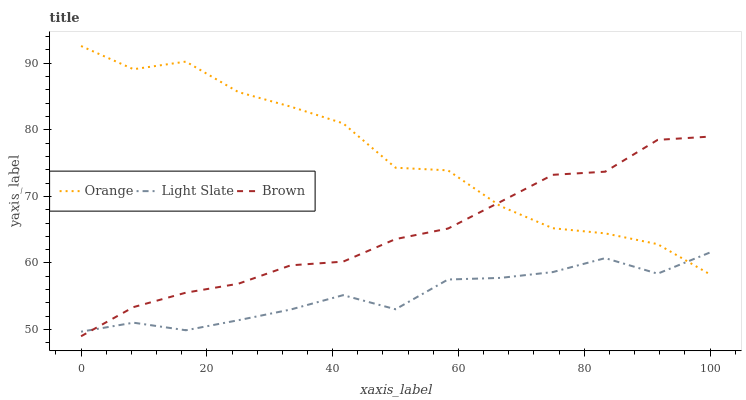Does Light Slate have the minimum area under the curve?
Answer yes or no. Yes. Does Orange have the maximum area under the curve?
Answer yes or no. Yes. Does Brown have the minimum area under the curve?
Answer yes or no. No. Does Brown have the maximum area under the curve?
Answer yes or no. No. Is Brown the smoothest?
Answer yes or no. Yes. Is Orange the roughest?
Answer yes or no. Yes. Is Light Slate the smoothest?
Answer yes or no. No. Is Light Slate the roughest?
Answer yes or no. No. Does Brown have the lowest value?
Answer yes or no. Yes. Does Light Slate have the lowest value?
Answer yes or no. No. Does Orange have the highest value?
Answer yes or no. Yes. Does Brown have the highest value?
Answer yes or no. No. Does Brown intersect Light Slate?
Answer yes or no. Yes. Is Brown less than Light Slate?
Answer yes or no. No. Is Brown greater than Light Slate?
Answer yes or no. No. 